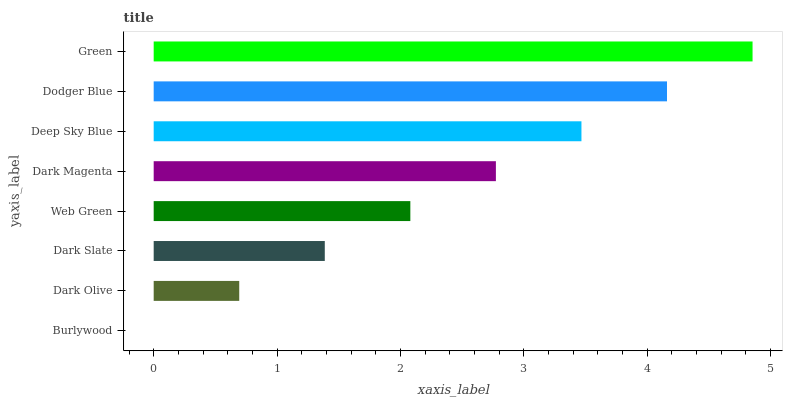Is Burlywood the minimum?
Answer yes or no. Yes. Is Green the maximum?
Answer yes or no. Yes. Is Dark Olive the minimum?
Answer yes or no. No. Is Dark Olive the maximum?
Answer yes or no. No. Is Dark Olive greater than Burlywood?
Answer yes or no. Yes. Is Burlywood less than Dark Olive?
Answer yes or no. Yes. Is Burlywood greater than Dark Olive?
Answer yes or no. No. Is Dark Olive less than Burlywood?
Answer yes or no. No. Is Dark Magenta the high median?
Answer yes or no. Yes. Is Web Green the low median?
Answer yes or no. Yes. Is Dodger Blue the high median?
Answer yes or no. No. Is Deep Sky Blue the low median?
Answer yes or no. No. 